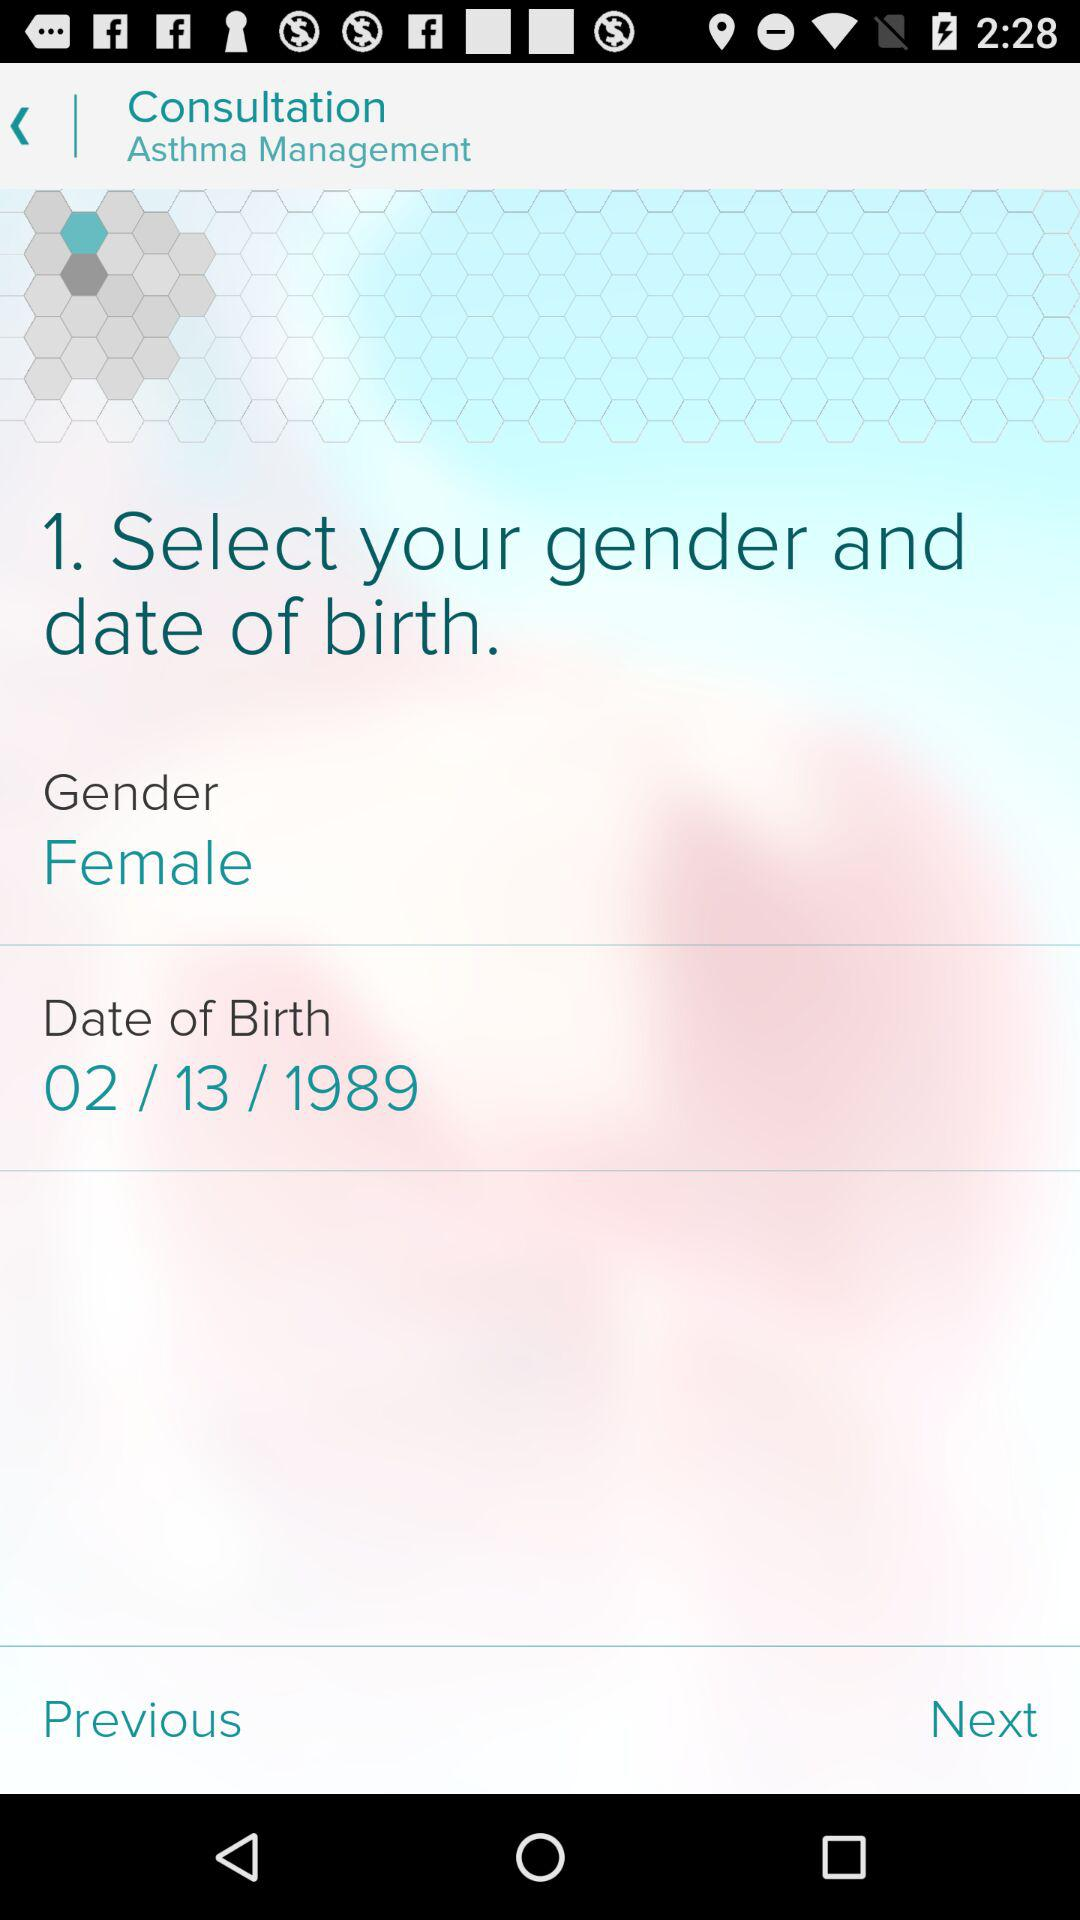What is the selected gender? The selected gender is female. 